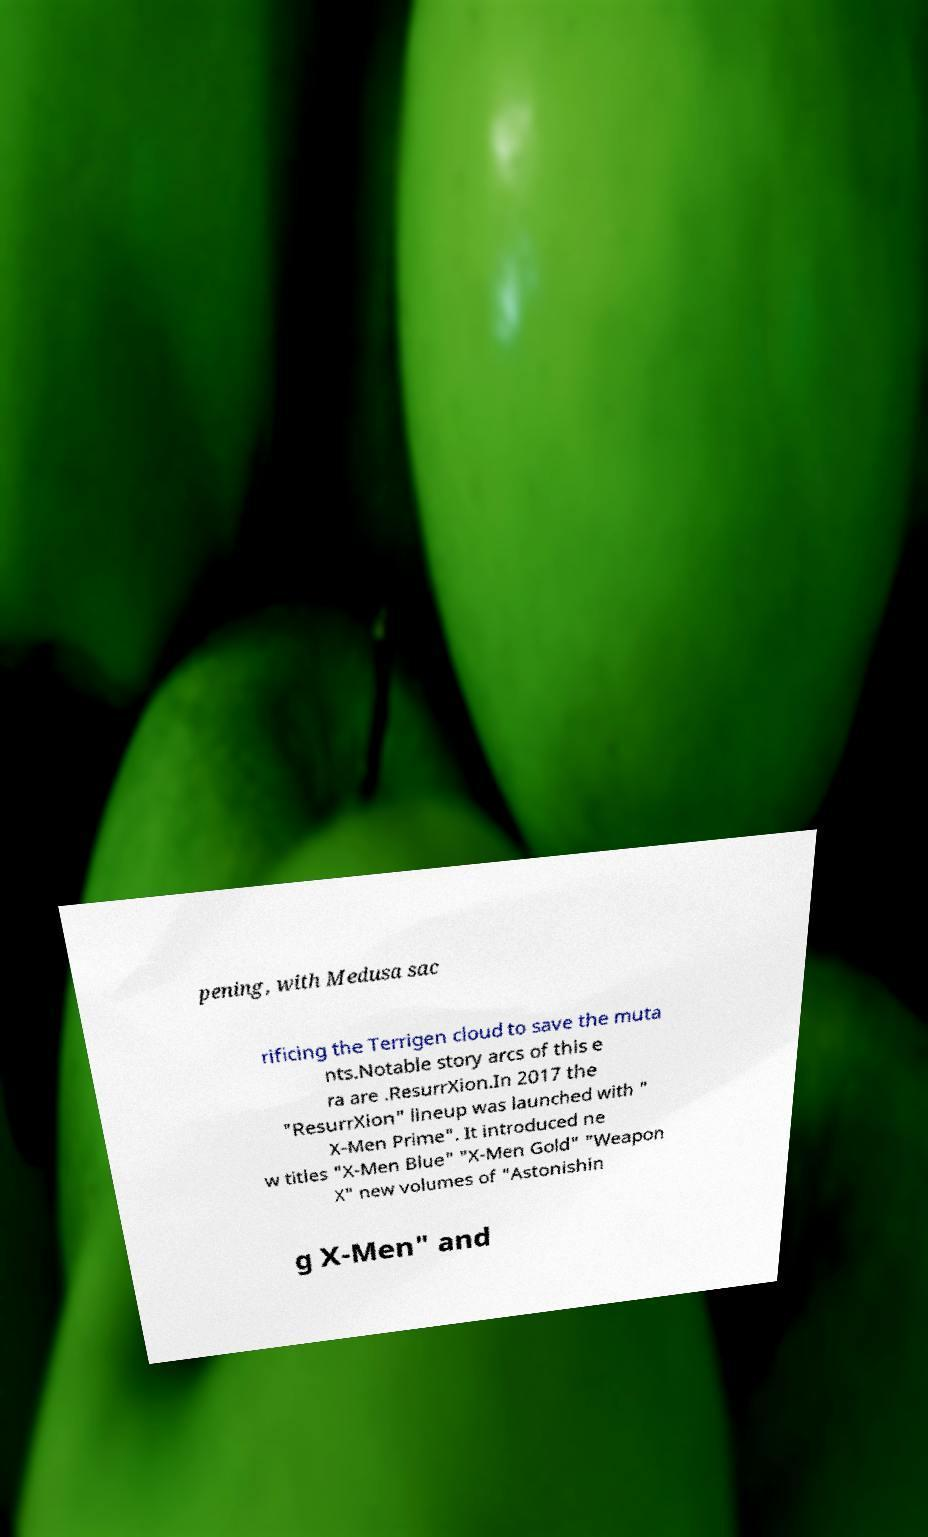Can you read and provide the text displayed in the image?This photo seems to have some interesting text. Can you extract and type it out for me? pening, with Medusa sac rificing the Terrigen cloud to save the muta nts.Notable story arcs of this e ra are .ResurrXion.In 2017 the "ResurrXion" lineup was launched with " X-Men Prime". It introduced ne w titles "X-Men Blue" "X-Men Gold" "Weapon X" new volumes of "Astonishin g X-Men" and 